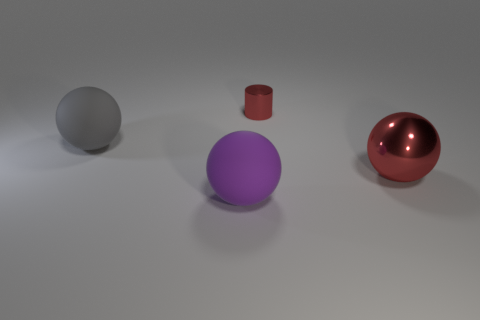What is the overall mood or atmosphere conveyed by the image? The image conveys a serene and simplistic atmosphere, marked by soft lighting and a lack of background noise. The muted color palette and uncluttered composition evoke a sense of calmness and order. 